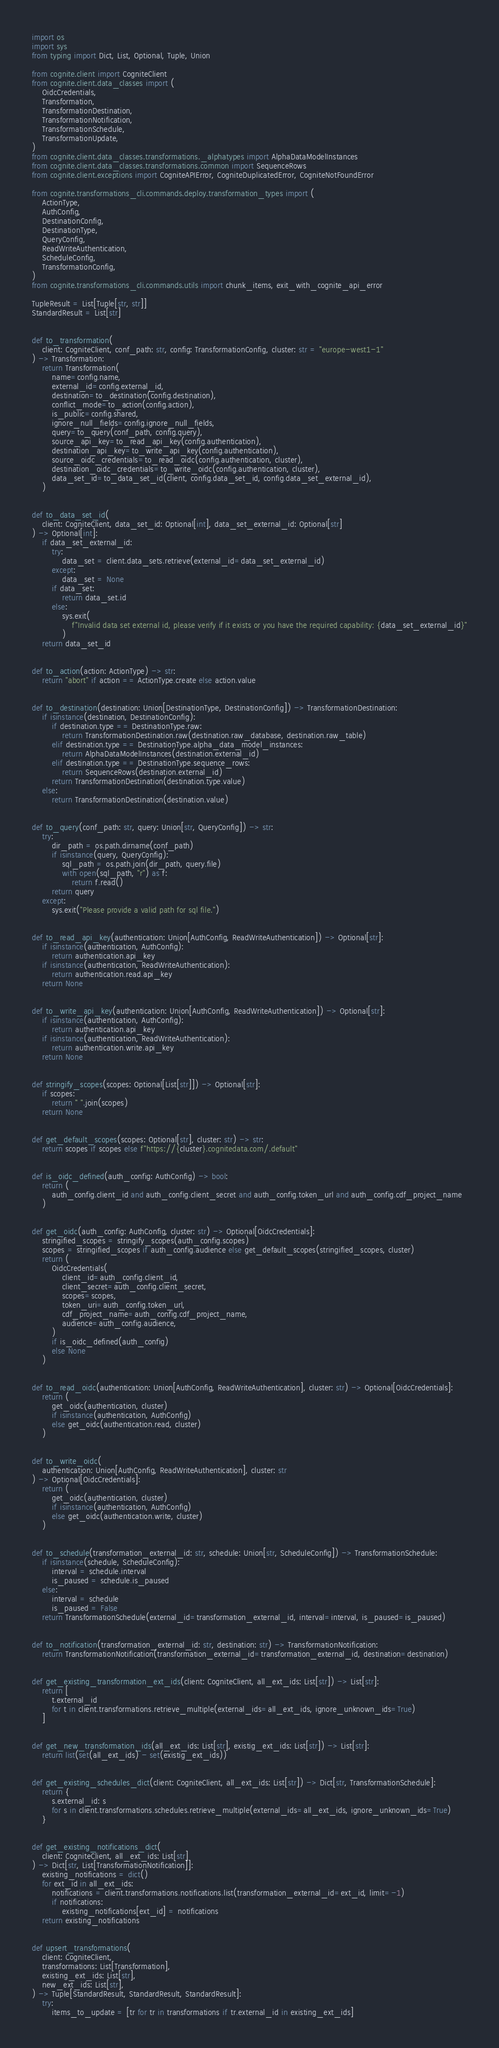<code> <loc_0><loc_0><loc_500><loc_500><_Python_>import os
import sys
from typing import Dict, List, Optional, Tuple, Union

from cognite.client import CogniteClient
from cognite.client.data_classes import (
    OidcCredentials,
    Transformation,
    TransformationDestination,
    TransformationNotification,
    TransformationSchedule,
    TransformationUpdate,
)
from cognite.client.data_classes.transformations._alphatypes import AlphaDataModelInstances
from cognite.client.data_classes.transformations.common import SequenceRows
from cognite.client.exceptions import CogniteAPIError, CogniteDuplicatedError, CogniteNotFoundError

from cognite.transformations_cli.commands.deploy.transformation_types import (
    ActionType,
    AuthConfig,
    DestinationConfig,
    DestinationType,
    QueryConfig,
    ReadWriteAuthentication,
    ScheduleConfig,
    TransformationConfig,
)
from cognite.transformations_cli.commands.utils import chunk_items, exit_with_cognite_api_error

TupleResult = List[Tuple[str, str]]
StandardResult = List[str]


def to_transformation(
    client: CogniteClient, conf_path: str, config: TransformationConfig, cluster: str = "europe-west1-1"
) -> Transformation:
    return Transformation(
        name=config.name,
        external_id=config.external_id,
        destination=to_destination(config.destination),
        conflict_mode=to_action(config.action),
        is_public=config.shared,
        ignore_null_fields=config.ignore_null_fields,
        query=to_query(conf_path, config.query),
        source_api_key=to_read_api_key(config.authentication),
        destination_api_key=to_write_api_key(config.authentication),
        source_oidc_credentials=to_read_oidc(config.authentication, cluster),
        destination_oidc_credentials=to_write_oidc(config.authentication, cluster),
        data_set_id=to_data_set_id(client, config.data_set_id, config.data_set_external_id),
    )


def to_data_set_id(
    client: CogniteClient, data_set_id: Optional[int], data_set_external_id: Optional[str]
) -> Optional[int]:
    if data_set_external_id:
        try:
            data_set = client.data_sets.retrieve(external_id=data_set_external_id)
        except:
            data_set = None
        if data_set:
            return data_set.id
        else:
            sys.exit(
                f"Invalid data set external id, please verify if it exists or you have the required capability: {data_set_external_id}"
            )
    return data_set_id


def to_action(action: ActionType) -> str:
    return "abort" if action == ActionType.create else action.value


def to_destination(destination: Union[DestinationType, DestinationConfig]) -> TransformationDestination:
    if isinstance(destination, DestinationConfig):
        if destination.type == DestinationType.raw:
            return TransformationDestination.raw(destination.raw_database, destination.raw_table)
        elif destination.type == DestinationType.alpha_data_model_instances:
            return AlphaDataModelInstances(destination.external_id)
        elif destination.type == DestinationType.sequence_rows:
            return SequenceRows(destination.external_id)
        return TransformationDestination(destination.type.value)
    else:
        return TransformationDestination(destination.value)


def to_query(conf_path: str, query: Union[str, QueryConfig]) -> str:
    try:
        dir_path = os.path.dirname(conf_path)
        if isinstance(query, QueryConfig):
            sql_path = os.path.join(dir_path, query.file)
            with open(sql_path, "r") as f:
                return f.read()
        return query
    except:
        sys.exit("Please provide a valid path for sql file.")


def to_read_api_key(authentication: Union[AuthConfig, ReadWriteAuthentication]) -> Optional[str]:
    if isinstance(authentication, AuthConfig):
        return authentication.api_key
    if isinstance(authentication, ReadWriteAuthentication):
        return authentication.read.api_key
    return None


def to_write_api_key(authentication: Union[AuthConfig, ReadWriteAuthentication]) -> Optional[str]:
    if isinstance(authentication, AuthConfig):
        return authentication.api_key
    if isinstance(authentication, ReadWriteAuthentication):
        return authentication.write.api_key
    return None


def stringify_scopes(scopes: Optional[List[str]]) -> Optional[str]:
    if scopes:
        return " ".join(scopes)
    return None


def get_default_scopes(scopes: Optional[str], cluster: str) -> str:
    return scopes if scopes else f"https://{cluster}.cognitedata.com/.default"


def is_oidc_defined(auth_config: AuthConfig) -> bool:
    return (
        auth_config.client_id and auth_config.client_secret and auth_config.token_url and auth_config.cdf_project_name
    )


def get_oidc(auth_config: AuthConfig, cluster: str) -> Optional[OidcCredentials]:
    stringified_scopes = stringify_scopes(auth_config.scopes)
    scopes = stringified_scopes if auth_config.audience else get_default_scopes(stringified_scopes, cluster)
    return (
        OidcCredentials(
            client_id=auth_config.client_id,
            client_secret=auth_config.client_secret,
            scopes=scopes,
            token_uri=auth_config.token_url,
            cdf_project_name=auth_config.cdf_project_name,
            audience=auth_config.audience,
        )
        if is_oidc_defined(auth_config)
        else None
    )


def to_read_oidc(authentication: Union[AuthConfig, ReadWriteAuthentication], cluster: str) -> Optional[OidcCredentials]:
    return (
        get_oidc(authentication, cluster)
        if isinstance(authentication, AuthConfig)
        else get_oidc(authentication.read, cluster)
    )


def to_write_oidc(
    authentication: Union[AuthConfig, ReadWriteAuthentication], cluster: str
) -> Optional[OidcCredentials]:
    return (
        get_oidc(authentication, cluster)
        if isinstance(authentication, AuthConfig)
        else get_oidc(authentication.write, cluster)
    )


def to_schedule(transformation_external_id: str, schedule: Union[str, ScheduleConfig]) -> TransformationSchedule:
    if isinstance(schedule, ScheduleConfig):
        interval = schedule.interval
        is_paused = schedule.is_paused
    else:
        interval = schedule
        is_paused = False
    return TransformationSchedule(external_id=transformation_external_id, interval=interval, is_paused=is_paused)


def to_notification(transformation_external_id: str, destination: str) -> TransformationNotification:
    return TransformationNotification(transformation_external_id=transformation_external_id, destination=destination)


def get_existing_transformation_ext_ids(client: CogniteClient, all_ext_ids: List[str]) -> List[str]:
    return [
        t.external_id
        for t in client.transformations.retrieve_multiple(external_ids=all_ext_ids, ignore_unknown_ids=True)
    ]


def get_new_transformation_ids(all_ext_ids: List[str], existig_ext_ids: List[str]) -> List[str]:
    return list(set(all_ext_ids) - set(existig_ext_ids))


def get_existing_schedules_dict(client: CogniteClient, all_ext_ids: List[str]) -> Dict[str, TransformationSchedule]:
    return {
        s.external_id: s
        for s in client.transformations.schedules.retrieve_multiple(external_ids=all_ext_ids, ignore_unknown_ids=True)
    }


def get_existing_notifications_dict(
    client: CogniteClient, all_ext_ids: List[str]
) -> Dict[str, List[TransformationNotification]]:
    existing_notifications = dict()
    for ext_id in all_ext_ids:
        notifications = client.transformations.notifications.list(transformation_external_id=ext_id, limit=-1)
        if notifications:
            existing_notifications[ext_id] = notifications
    return existing_notifications


def upsert_transformations(
    client: CogniteClient,
    transformations: List[Transformation],
    existing_ext_ids: List[str],
    new_ext_ids: List[str],
) -> Tuple[StandardResult, StandardResult, StandardResult]:
    try:
        items_to_update = [tr for tr in transformations if tr.external_id in existing_ext_ids]</code> 